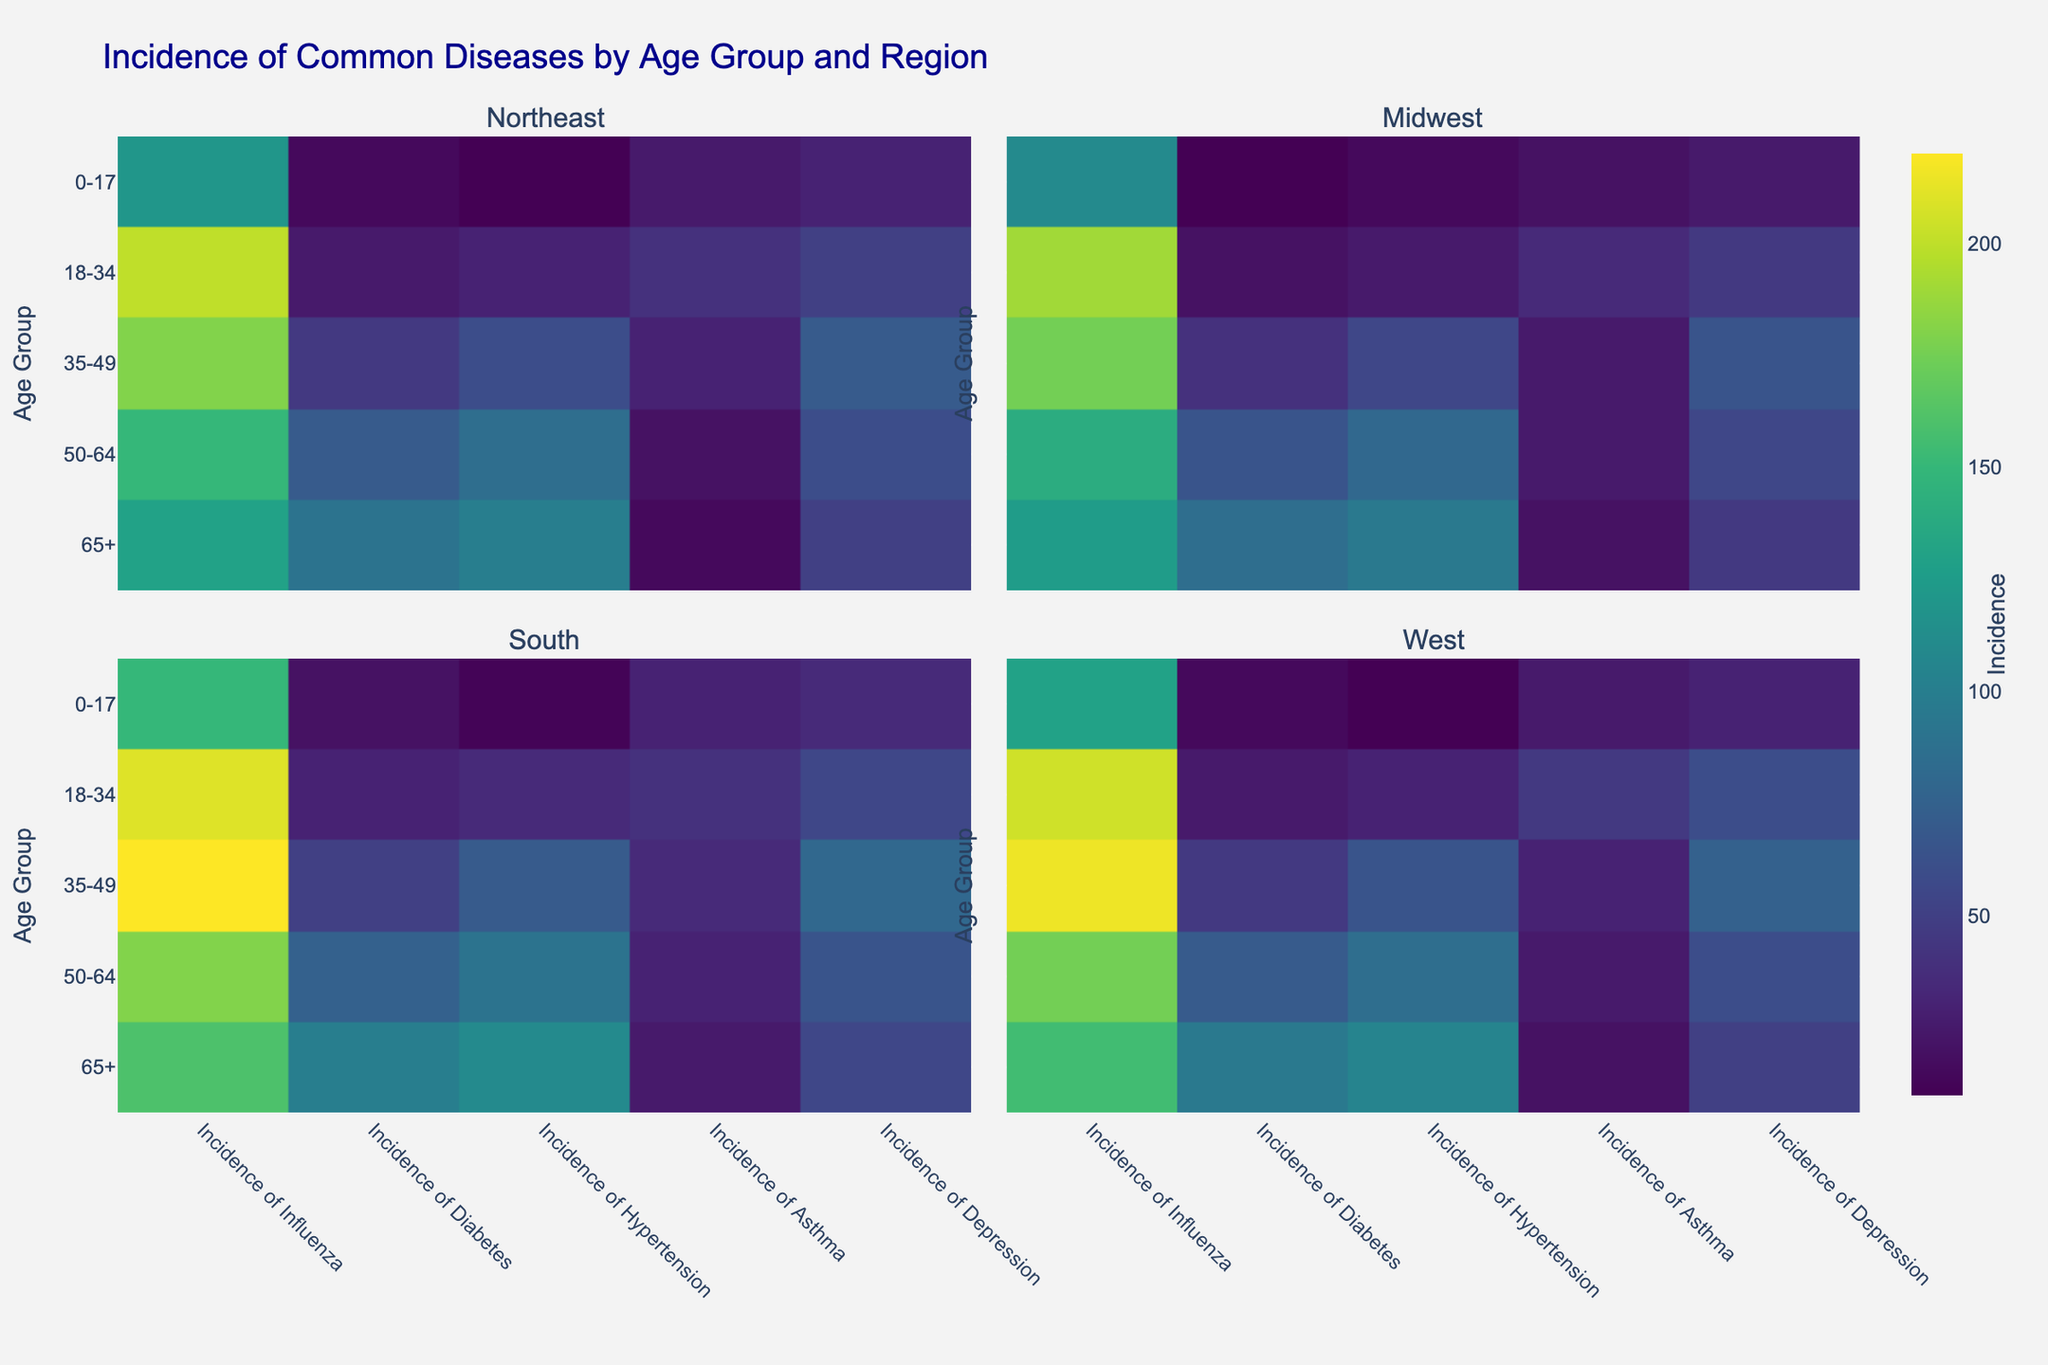What is the title of the heatmap? The title is displayed at the top of the heatmap and provides a brief description of what the visualization represents. In this case, the title is "Incidence of Common Diseases by Age Group and Region."
Answer: Incidence of Common Diseases by Age Group and Region Which region shows the highest incidence of hypertension for age group 35-49? The heatmap has different facets for each region, and you can locate the 35-49 age group and compare the color intensity for hypertension across these regions. The South region has the darkest color, indicating the highest incidence.
Answer: South Compare the incidence of influenza between the 0-17 age group in the South and the 50-64 age group in the West. Which group has a higher incidence? To determine this, look at the color intensity for influenza in the specified age groups and regions. For the 0-17 group in the South, the value is 150. For the 50-64 group in the West, the value is 175. The 50-64 age group in the West has a higher incidence.
Answer: 50-64 age group in the West What is the incidence of depression for the 18-34 age group in the West region? Find the intersection of the 18-34 age group and the 'Depression' column in the West region's facet. The corresponding color intensity and value indicate the incidence.
Answer: 60 In which age group and region do we see the lowest incidence of diabetes? Review the color intensities for diabetes across all age groups and regions. The lightest color indicates the lowest incidence, which is for the 0-17 age group in the Midwest, with an incidence of 10.
Answer: 0-17 age group in the Midwest Calculate the average incidence of asthma for the 65+ age group across all regions. Extract the values for asthma in the 65+ age group for all regions, which are 15, 20, 25, and 20. Sum them up: 15 + 20 + 25 + 20 = 80. Then, divide by 4 (the number of regions): 80 / 4 = 20.
Answer: 20 Which common disease shows the highest incidence overall for any age group and region? Scan the heatmap for the darkest color, indicating the highest value. The highest incidence value is for asthma in the 18-34 group in the West, with an incidence of 45.
Answer: Asthma in the 18-34 group in the West What is the relationship between the incidences of depression and diabetes in the 50-64 age group in the South? Compare the color intensities and values for depression and diabetes in the 50-64 age group in the South. Depression has an incidence of 65, and diabetes has an incidence of 75. Therefore, the incidence of diabetes is higher.
Answer: Diabetes has a higher incidence Identify the age group and region with the smallest difference between the incidences of hypertension and influenza. Calculate the difference between the incidences of hypertension and influenza for each age group and region. The smallest difference is for the 0-17 age group in the Northeast, where hypertension is 10 and influenza is 120, with a difference of 110.
Answer: 0-17 age group in the Northeast 